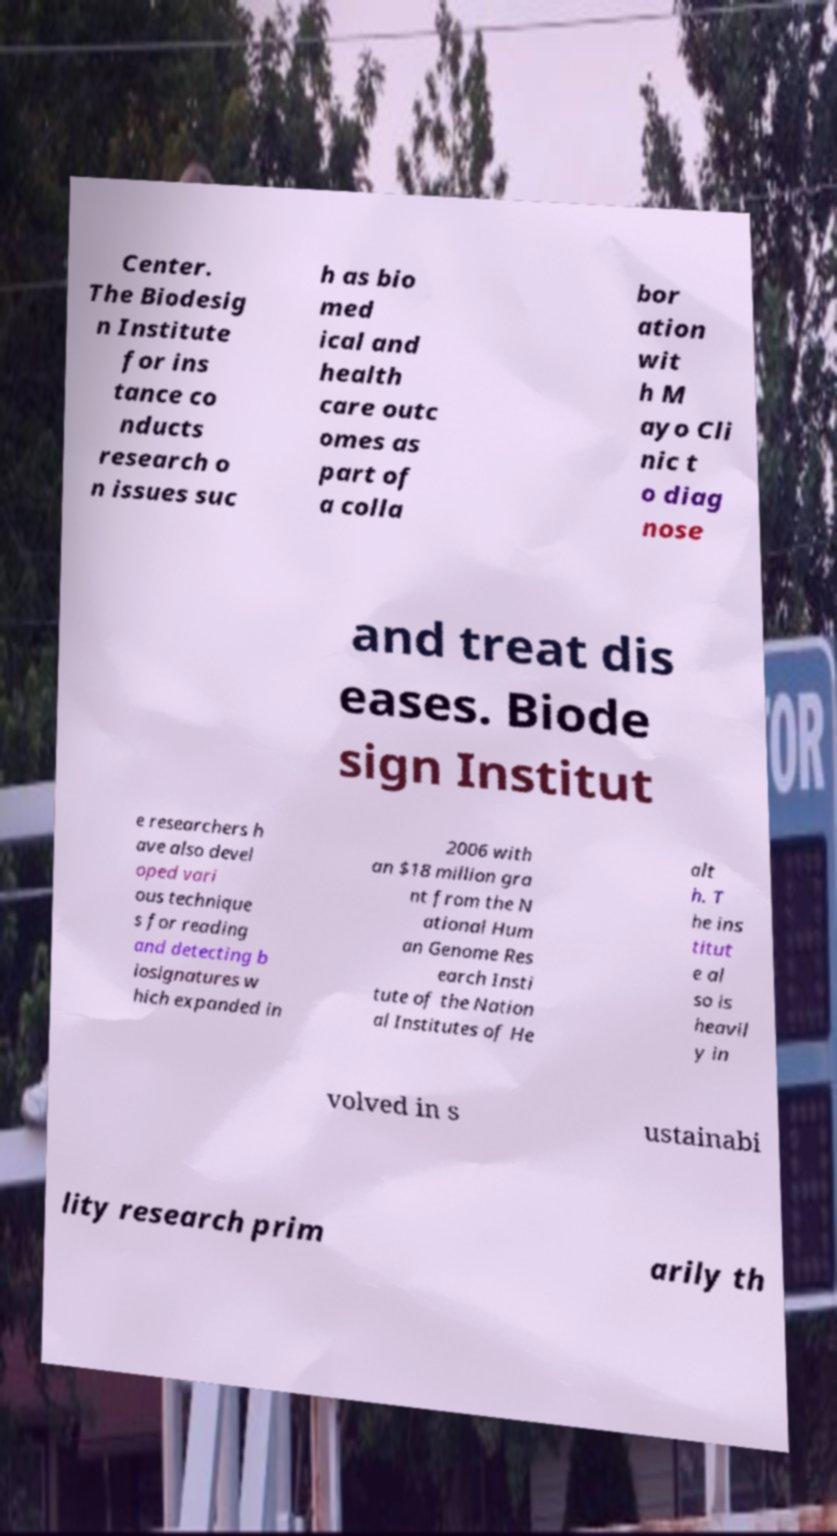Can you accurately transcribe the text from the provided image for me? Center. The Biodesig n Institute for ins tance co nducts research o n issues suc h as bio med ical and health care outc omes as part of a colla bor ation wit h M ayo Cli nic t o diag nose and treat dis eases. Biode sign Institut e researchers h ave also devel oped vari ous technique s for reading and detecting b iosignatures w hich expanded in 2006 with an $18 million gra nt from the N ational Hum an Genome Res earch Insti tute of the Nation al Institutes of He alt h. T he ins titut e al so is heavil y in volved in s ustainabi lity research prim arily th 